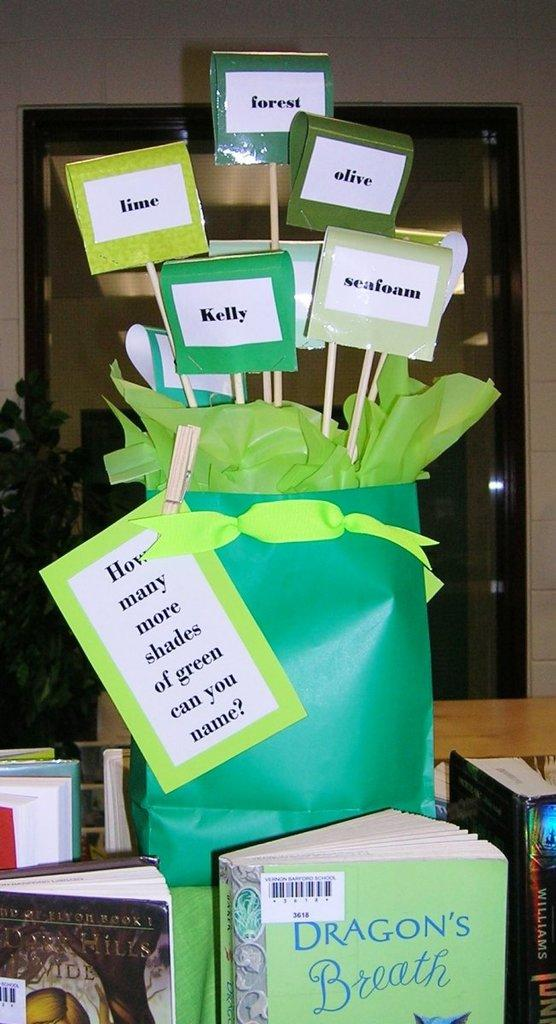<image>
Share a concise interpretation of the image provided. A display in the classroom about the book Dragon's Breath. 